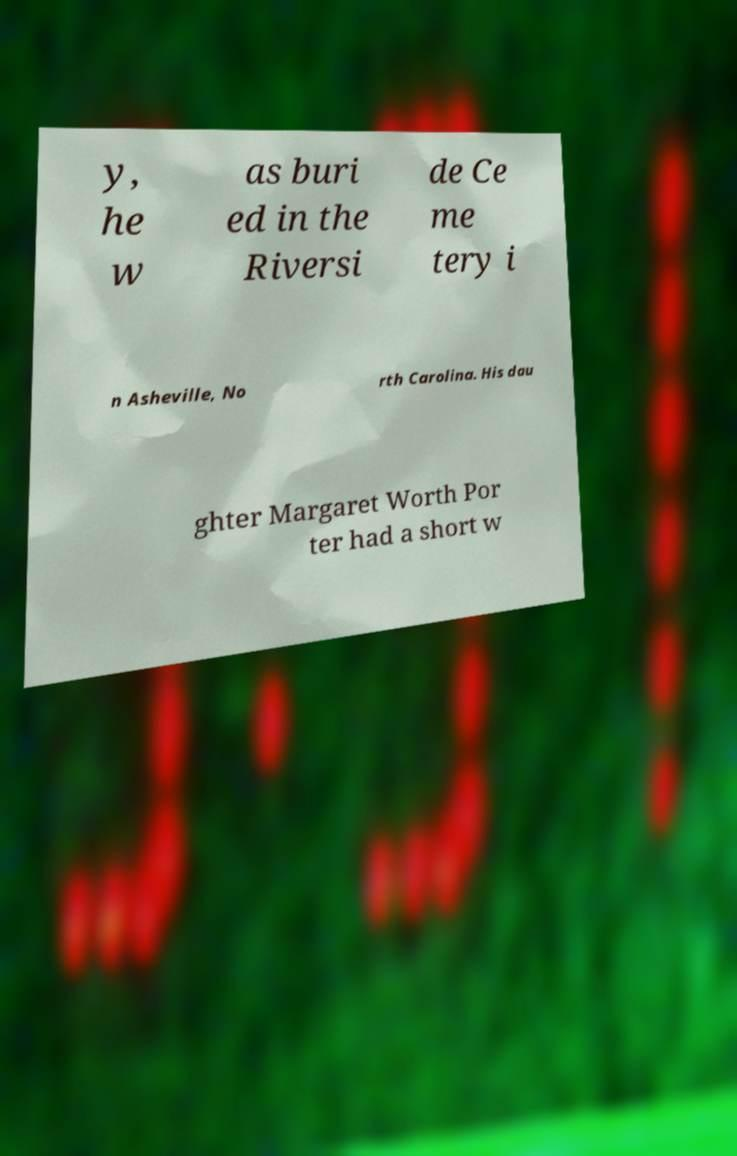Can you accurately transcribe the text from the provided image for me? y, he w as buri ed in the Riversi de Ce me tery i n Asheville, No rth Carolina. His dau ghter Margaret Worth Por ter had a short w 